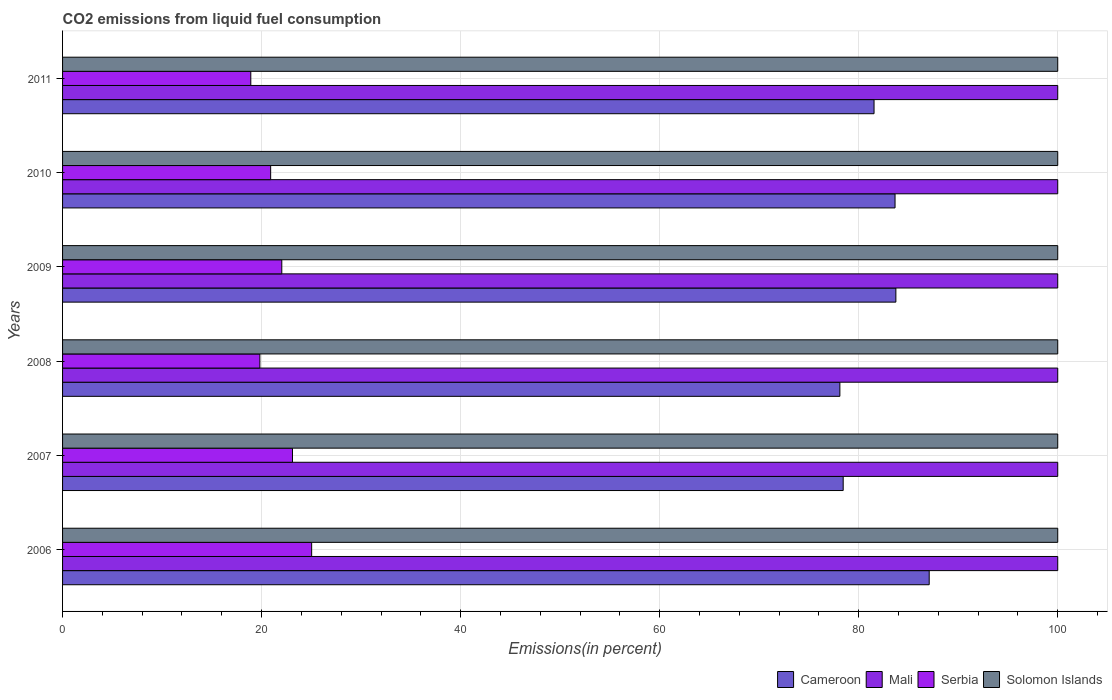Are the number of bars on each tick of the Y-axis equal?
Your answer should be compact. Yes. What is the label of the 6th group of bars from the top?
Give a very brief answer. 2006. In how many cases, is the number of bars for a given year not equal to the number of legend labels?
Your answer should be very brief. 0. What is the total CO2 emitted in Solomon Islands in 2006?
Your answer should be compact. 100. Across all years, what is the maximum total CO2 emitted in Solomon Islands?
Provide a succinct answer. 100. Across all years, what is the minimum total CO2 emitted in Serbia?
Keep it short and to the point. 18.91. In which year was the total CO2 emitted in Cameroon maximum?
Ensure brevity in your answer.  2006. In which year was the total CO2 emitted in Serbia minimum?
Give a very brief answer. 2011. What is the total total CO2 emitted in Solomon Islands in the graph?
Provide a succinct answer. 600. What is the difference between the total CO2 emitted in Cameroon in 2010 and that in 2011?
Make the answer very short. 2.11. What is the difference between the total CO2 emitted in Cameroon in 2006 and the total CO2 emitted in Mali in 2008?
Provide a short and direct response. -12.92. In the year 2008, what is the difference between the total CO2 emitted in Serbia and total CO2 emitted in Solomon Islands?
Your response must be concise. -80.17. In how many years, is the total CO2 emitted in Cameroon greater than 84 %?
Give a very brief answer. 1. What is the ratio of the total CO2 emitted in Cameroon in 2007 to that in 2010?
Your answer should be very brief. 0.94. Is the total CO2 emitted in Cameroon in 2008 less than that in 2011?
Keep it short and to the point. Yes. What is the difference between the highest and the second highest total CO2 emitted in Solomon Islands?
Give a very brief answer. 0. What is the difference between the highest and the lowest total CO2 emitted in Cameroon?
Give a very brief answer. 8.98. In how many years, is the total CO2 emitted in Serbia greater than the average total CO2 emitted in Serbia taken over all years?
Give a very brief answer. 3. Is the sum of the total CO2 emitted in Solomon Islands in 2009 and 2011 greater than the maximum total CO2 emitted in Cameroon across all years?
Offer a very short reply. Yes. Is it the case that in every year, the sum of the total CO2 emitted in Mali and total CO2 emitted in Serbia is greater than the sum of total CO2 emitted in Cameroon and total CO2 emitted in Solomon Islands?
Your response must be concise. No. What does the 1st bar from the top in 2007 represents?
Your response must be concise. Solomon Islands. What does the 4th bar from the bottom in 2008 represents?
Give a very brief answer. Solomon Islands. Are all the bars in the graph horizontal?
Offer a very short reply. Yes. How many years are there in the graph?
Your answer should be very brief. 6. Are the values on the major ticks of X-axis written in scientific E-notation?
Give a very brief answer. No. Does the graph contain any zero values?
Make the answer very short. No. Where does the legend appear in the graph?
Give a very brief answer. Bottom right. What is the title of the graph?
Your response must be concise. CO2 emissions from liquid fuel consumption. What is the label or title of the X-axis?
Keep it short and to the point. Emissions(in percent). What is the label or title of the Y-axis?
Keep it short and to the point. Years. What is the Emissions(in percent) of Cameroon in 2006?
Provide a succinct answer. 87.08. What is the Emissions(in percent) of Serbia in 2006?
Your response must be concise. 25.03. What is the Emissions(in percent) in Solomon Islands in 2006?
Give a very brief answer. 100. What is the Emissions(in percent) in Cameroon in 2007?
Your answer should be very brief. 78.44. What is the Emissions(in percent) in Mali in 2007?
Offer a terse response. 100. What is the Emissions(in percent) in Serbia in 2007?
Your answer should be very brief. 23.1. What is the Emissions(in percent) in Solomon Islands in 2007?
Keep it short and to the point. 100. What is the Emissions(in percent) of Cameroon in 2008?
Your answer should be compact. 78.11. What is the Emissions(in percent) of Mali in 2008?
Offer a very short reply. 100. What is the Emissions(in percent) in Serbia in 2008?
Your response must be concise. 19.83. What is the Emissions(in percent) of Solomon Islands in 2008?
Make the answer very short. 100. What is the Emissions(in percent) of Cameroon in 2009?
Provide a short and direct response. 83.74. What is the Emissions(in percent) of Serbia in 2009?
Provide a short and direct response. 22.03. What is the Emissions(in percent) in Solomon Islands in 2009?
Provide a succinct answer. 100. What is the Emissions(in percent) in Cameroon in 2010?
Provide a succinct answer. 83.65. What is the Emissions(in percent) of Mali in 2010?
Your answer should be very brief. 100. What is the Emissions(in percent) in Serbia in 2010?
Keep it short and to the point. 20.91. What is the Emissions(in percent) of Solomon Islands in 2010?
Your answer should be very brief. 100. What is the Emissions(in percent) of Cameroon in 2011?
Offer a very short reply. 81.54. What is the Emissions(in percent) in Mali in 2011?
Your answer should be compact. 100. What is the Emissions(in percent) of Serbia in 2011?
Make the answer very short. 18.91. What is the Emissions(in percent) in Solomon Islands in 2011?
Offer a terse response. 100. Across all years, what is the maximum Emissions(in percent) in Cameroon?
Make the answer very short. 87.08. Across all years, what is the maximum Emissions(in percent) in Serbia?
Provide a short and direct response. 25.03. Across all years, what is the minimum Emissions(in percent) of Cameroon?
Your answer should be compact. 78.11. Across all years, what is the minimum Emissions(in percent) of Serbia?
Your answer should be very brief. 18.91. What is the total Emissions(in percent) of Cameroon in the graph?
Make the answer very short. 492.56. What is the total Emissions(in percent) of Mali in the graph?
Keep it short and to the point. 600. What is the total Emissions(in percent) of Serbia in the graph?
Your answer should be very brief. 129.81. What is the total Emissions(in percent) in Solomon Islands in the graph?
Offer a terse response. 600. What is the difference between the Emissions(in percent) of Cameroon in 2006 and that in 2007?
Your response must be concise. 8.64. What is the difference between the Emissions(in percent) in Serbia in 2006 and that in 2007?
Provide a short and direct response. 1.93. What is the difference between the Emissions(in percent) in Cameroon in 2006 and that in 2008?
Make the answer very short. 8.98. What is the difference between the Emissions(in percent) in Serbia in 2006 and that in 2008?
Your answer should be compact. 5.2. What is the difference between the Emissions(in percent) of Solomon Islands in 2006 and that in 2008?
Ensure brevity in your answer.  0. What is the difference between the Emissions(in percent) in Cameroon in 2006 and that in 2009?
Provide a succinct answer. 3.35. What is the difference between the Emissions(in percent) of Mali in 2006 and that in 2009?
Ensure brevity in your answer.  0. What is the difference between the Emissions(in percent) in Serbia in 2006 and that in 2009?
Your answer should be compact. 3. What is the difference between the Emissions(in percent) of Cameroon in 2006 and that in 2010?
Give a very brief answer. 3.43. What is the difference between the Emissions(in percent) of Serbia in 2006 and that in 2010?
Provide a short and direct response. 4.12. What is the difference between the Emissions(in percent) in Cameroon in 2006 and that in 2011?
Provide a succinct answer. 5.54. What is the difference between the Emissions(in percent) of Serbia in 2006 and that in 2011?
Keep it short and to the point. 6.12. What is the difference between the Emissions(in percent) in Cameroon in 2007 and that in 2008?
Make the answer very short. 0.33. What is the difference between the Emissions(in percent) in Mali in 2007 and that in 2008?
Your answer should be compact. 0. What is the difference between the Emissions(in percent) in Serbia in 2007 and that in 2008?
Provide a succinct answer. 3.28. What is the difference between the Emissions(in percent) of Solomon Islands in 2007 and that in 2008?
Offer a terse response. 0. What is the difference between the Emissions(in percent) in Cameroon in 2007 and that in 2009?
Your response must be concise. -5.29. What is the difference between the Emissions(in percent) of Mali in 2007 and that in 2009?
Offer a terse response. 0. What is the difference between the Emissions(in percent) of Serbia in 2007 and that in 2009?
Offer a terse response. 1.07. What is the difference between the Emissions(in percent) of Solomon Islands in 2007 and that in 2009?
Make the answer very short. 0. What is the difference between the Emissions(in percent) in Cameroon in 2007 and that in 2010?
Offer a very short reply. -5.21. What is the difference between the Emissions(in percent) in Serbia in 2007 and that in 2010?
Your answer should be compact. 2.19. What is the difference between the Emissions(in percent) in Solomon Islands in 2007 and that in 2010?
Provide a succinct answer. 0. What is the difference between the Emissions(in percent) of Cameroon in 2007 and that in 2011?
Provide a succinct answer. -3.1. What is the difference between the Emissions(in percent) of Serbia in 2007 and that in 2011?
Provide a short and direct response. 4.19. What is the difference between the Emissions(in percent) in Cameroon in 2008 and that in 2009?
Provide a short and direct response. -5.63. What is the difference between the Emissions(in percent) in Serbia in 2008 and that in 2009?
Offer a terse response. -2.2. What is the difference between the Emissions(in percent) of Cameroon in 2008 and that in 2010?
Offer a terse response. -5.54. What is the difference between the Emissions(in percent) in Mali in 2008 and that in 2010?
Your answer should be compact. 0. What is the difference between the Emissions(in percent) of Serbia in 2008 and that in 2010?
Your answer should be compact. -1.08. What is the difference between the Emissions(in percent) in Solomon Islands in 2008 and that in 2010?
Keep it short and to the point. 0. What is the difference between the Emissions(in percent) in Cameroon in 2008 and that in 2011?
Your response must be concise. -3.43. What is the difference between the Emissions(in percent) in Serbia in 2008 and that in 2011?
Your answer should be compact. 0.91. What is the difference between the Emissions(in percent) of Cameroon in 2009 and that in 2010?
Keep it short and to the point. 0.08. What is the difference between the Emissions(in percent) in Serbia in 2009 and that in 2010?
Your answer should be compact. 1.12. What is the difference between the Emissions(in percent) of Cameroon in 2009 and that in 2011?
Your answer should be compact. 2.19. What is the difference between the Emissions(in percent) in Serbia in 2009 and that in 2011?
Your response must be concise. 3.11. What is the difference between the Emissions(in percent) of Solomon Islands in 2009 and that in 2011?
Your response must be concise. 0. What is the difference between the Emissions(in percent) of Cameroon in 2010 and that in 2011?
Provide a short and direct response. 2.11. What is the difference between the Emissions(in percent) of Serbia in 2010 and that in 2011?
Provide a short and direct response. 2. What is the difference between the Emissions(in percent) of Cameroon in 2006 and the Emissions(in percent) of Mali in 2007?
Provide a succinct answer. -12.92. What is the difference between the Emissions(in percent) of Cameroon in 2006 and the Emissions(in percent) of Serbia in 2007?
Your answer should be compact. 63.98. What is the difference between the Emissions(in percent) in Cameroon in 2006 and the Emissions(in percent) in Solomon Islands in 2007?
Your answer should be compact. -12.92. What is the difference between the Emissions(in percent) of Mali in 2006 and the Emissions(in percent) of Serbia in 2007?
Keep it short and to the point. 76.9. What is the difference between the Emissions(in percent) in Mali in 2006 and the Emissions(in percent) in Solomon Islands in 2007?
Give a very brief answer. 0. What is the difference between the Emissions(in percent) in Serbia in 2006 and the Emissions(in percent) in Solomon Islands in 2007?
Ensure brevity in your answer.  -74.97. What is the difference between the Emissions(in percent) of Cameroon in 2006 and the Emissions(in percent) of Mali in 2008?
Make the answer very short. -12.92. What is the difference between the Emissions(in percent) in Cameroon in 2006 and the Emissions(in percent) in Serbia in 2008?
Your answer should be compact. 67.26. What is the difference between the Emissions(in percent) of Cameroon in 2006 and the Emissions(in percent) of Solomon Islands in 2008?
Make the answer very short. -12.92. What is the difference between the Emissions(in percent) of Mali in 2006 and the Emissions(in percent) of Serbia in 2008?
Your response must be concise. 80.17. What is the difference between the Emissions(in percent) of Serbia in 2006 and the Emissions(in percent) of Solomon Islands in 2008?
Your response must be concise. -74.97. What is the difference between the Emissions(in percent) in Cameroon in 2006 and the Emissions(in percent) in Mali in 2009?
Provide a succinct answer. -12.92. What is the difference between the Emissions(in percent) of Cameroon in 2006 and the Emissions(in percent) of Serbia in 2009?
Offer a terse response. 65.06. What is the difference between the Emissions(in percent) of Cameroon in 2006 and the Emissions(in percent) of Solomon Islands in 2009?
Provide a succinct answer. -12.92. What is the difference between the Emissions(in percent) of Mali in 2006 and the Emissions(in percent) of Serbia in 2009?
Offer a very short reply. 77.97. What is the difference between the Emissions(in percent) in Mali in 2006 and the Emissions(in percent) in Solomon Islands in 2009?
Offer a terse response. 0. What is the difference between the Emissions(in percent) in Serbia in 2006 and the Emissions(in percent) in Solomon Islands in 2009?
Your answer should be very brief. -74.97. What is the difference between the Emissions(in percent) in Cameroon in 2006 and the Emissions(in percent) in Mali in 2010?
Offer a very short reply. -12.92. What is the difference between the Emissions(in percent) of Cameroon in 2006 and the Emissions(in percent) of Serbia in 2010?
Offer a terse response. 66.17. What is the difference between the Emissions(in percent) in Cameroon in 2006 and the Emissions(in percent) in Solomon Islands in 2010?
Ensure brevity in your answer.  -12.92. What is the difference between the Emissions(in percent) of Mali in 2006 and the Emissions(in percent) of Serbia in 2010?
Provide a short and direct response. 79.09. What is the difference between the Emissions(in percent) in Mali in 2006 and the Emissions(in percent) in Solomon Islands in 2010?
Ensure brevity in your answer.  0. What is the difference between the Emissions(in percent) of Serbia in 2006 and the Emissions(in percent) of Solomon Islands in 2010?
Keep it short and to the point. -74.97. What is the difference between the Emissions(in percent) of Cameroon in 2006 and the Emissions(in percent) of Mali in 2011?
Offer a terse response. -12.92. What is the difference between the Emissions(in percent) in Cameroon in 2006 and the Emissions(in percent) in Serbia in 2011?
Keep it short and to the point. 68.17. What is the difference between the Emissions(in percent) in Cameroon in 2006 and the Emissions(in percent) in Solomon Islands in 2011?
Keep it short and to the point. -12.92. What is the difference between the Emissions(in percent) in Mali in 2006 and the Emissions(in percent) in Serbia in 2011?
Keep it short and to the point. 81.09. What is the difference between the Emissions(in percent) of Serbia in 2006 and the Emissions(in percent) of Solomon Islands in 2011?
Provide a succinct answer. -74.97. What is the difference between the Emissions(in percent) of Cameroon in 2007 and the Emissions(in percent) of Mali in 2008?
Provide a short and direct response. -21.56. What is the difference between the Emissions(in percent) in Cameroon in 2007 and the Emissions(in percent) in Serbia in 2008?
Make the answer very short. 58.62. What is the difference between the Emissions(in percent) in Cameroon in 2007 and the Emissions(in percent) in Solomon Islands in 2008?
Offer a terse response. -21.56. What is the difference between the Emissions(in percent) in Mali in 2007 and the Emissions(in percent) in Serbia in 2008?
Your answer should be very brief. 80.17. What is the difference between the Emissions(in percent) of Mali in 2007 and the Emissions(in percent) of Solomon Islands in 2008?
Offer a terse response. 0. What is the difference between the Emissions(in percent) in Serbia in 2007 and the Emissions(in percent) in Solomon Islands in 2008?
Your answer should be very brief. -76.9. What is the difference between the Emissions(in percent) of Cameroon in 2007 and the Emissions(in percent) of Mali in 2009?
Offer a very short reply. -21.56. What is the difference between the Emissions(in percent) in Cameroon in 2007 and the Emissions(in percent) in Serbia in 2009?
Keep it short and to the point. 56.41. What is the difference between the Emissions(in percent) in Cameroon in 2007 and the Emissions(in percent) in Solomon Islands in 2009?
Provide a short and direct response. -21.56. What is the difference between the Emissions(in percent) of Mali in 2007 and the Emissions(in percent) of Serbia in 2009?
Provide a succinct answer. 77.97. What is the difference between the Emissions(in percent) in Mali in 2007 and the Emissions(in percent) in Solomon Islands in 2009?
Provide a succinct answer. 0. What is the difference between the Emissions(in percent) in Serbia in 2007 and the Emissions(in percent) in Solomon Islands in 2009?
Provide a succinct answer. -76.9. What is the difference between the Emissions(in percent) in Cameroon in 2007 and the Emissions(in percent) in Mali in 2010?
Offer a terse response. -21.56. What is the difference between the Emissions(in percent) of Cameroon in 2007 and the Emissions(in percent) of Serbia in 2010?
Offer a very short reply. 57.53. What is the difference between the Emissions(in percent) of Cameroon in 2007 and the Emissions(in percent) of Solomon Islands in 2010?
Provide a succinct answer. -21.56. What is the difference between the Emissions(in percent) of Mali in 2007 and the Emissions(in percent) of Serbia in 2010?
Keep it short and to the point. 79.09. What is the difference between the Emissions(in percent) of Mali in 2007 and the Emissions(in percent) of Solomon Islands in 2010?
Provide a succinct answer. 0. What is the difference between the Emissions(in percent) in Serbia in 2007 and the Emissions(in percent) in Solomon Islands in 2010?
Offer a very short reply. -76.9. What is the difference between the Emissions(in percent) of Cameroon in 2007 and the Emissions(in percent) of Mali in 2011?
Your answer should be compact. -21.56. What is the difference between the Emissions(in percent) in Cameroon in 2007 and the Emissions(in percent) in Serbia in 2011?
Keep it short and to the point. 59.53. What is the difference between the Emissions(in percent) of Cameroon in 2007 and the Emissions(in percent) of Solomon Islands in 2011?
Offer a terse response. -21.56. What is the difference between the Emissions(in percent) in Mali in 2007 and the Emissions(in percent) in Serbia in 2011?
Offer a terse response. 81.09. What is the difference between the Emissions(in percent) of Mali in 2007 and the Emissions(in percent) of Solomon Islands in 2011?
Your answer should be very brief. 0. What is the difference between the Emissions(in percent) of Serbia in 2007 and the Emissions(in percent) of Solomon Islands in 2011?
Your answer should be compact. -76.9. What is the difference between the Emissions(in percent) of Cameroon in 2008 and the Emissions(in percent) of Mali in 2009?
Offer a terse response. -21.89. What is the difference between the Emissions(in percent) of Cameroon in 2008 and the Emissions(in percent) of Serbia in 2009?
Provide a succinct answer. 56.08. What is the difference between the Emissions(in percent) in Cameroon in 2008 and the Emissions(in percent) in Solomon Islands in 2009?
Your response must be concise. -21.89. What is the difference between the Emissions(in percent) of Mali in 2008 and the Emissions(in percent) of Serbia in 2009?
Ensure brevity in your answer.  77.97. What is the difference between the Emissions(in percent) in Serbia in 2008 and the Emissions(in percent) in Solomon Islands in 2009?
Make the answer very short. -80.17. What is the difference between the Emissions(in percent) in Cameroon in 2008 and the Emissions(in percent) in Mali in 2010?
Your answer should be very brief. -21.89. What is the difference between the Emissions(in percent) of Cameroon in 2008 and the Emissions(in percent) of Serbia in 2010?
Your response must be concise. 57.2. What is the difference between the Emissions(in percent) in Cameroon in 2008 and the Emissions(in percent) in Solomon Islands in 2010?
Your response must be concise. -21.89. What is the difference between the Emissions(in percent) in Mali in 2008 and the Emissions(in percent) in Serbia in 2010?
Give a very brief answer. 79.09. What is the difference between the Emissions(in percent) in Serbia in 2008 and the Emissions(in percent) in Solomon Islands in 2010?
Give a very brief answer. -80.17. What is the difference between the Emissions(in percent) in Cameroon in 2008 and the Emissions(in percent) in Mali in 2011?
Offer a very short reply. -21.89. What is the difference between the Emissions(in percent) in Cameroon in 2008 and the Emissions(in percent) in Serbia in 2011?
Give a very brief answer. 59.19. What is the difference between the Emissions(in percent) of Cameroon in 2008 and the Emissions(in percent) of Solomon Islands in 2011?
Keep it short and to the point. -21.89. What is the difference between the Emissions(in percent) in Mali in 2008 and the Emissions(in percent) in Serbia in 2011?
Provide a succinct answer. 81.09. What is the difference between the Emissions(in percent) in Serbia in 2008 and the Emissions(in percent) in Solomon Islands in 2011?
Ensure brevity in your answer.  -80.17. What is the difference between the Emissions(in percent) of Cameroon in 2009 and the Emissions(in percent) of Mali in 2010?
Provide a succinct answer. -16.26. What is the difference between the Emissions(in percent) in Cameroon in 2009 and the Emissions(in percent) in Serbia in 2010?
Give a very brief answer. 62.83. What is the difference between the Emissions(in percent) of Cameroon in 2009 and the Emissions(in percent) of Solomon Islands in 2010?
Keep it short and to the point. -16.26. What is the difference between the Emissions(in percent) in Mali in 2009 and the Emissions(in percent) in Serbia in 2010?
Ensure brevity in your answer.  79.09. What is the difference between the Emissions(in percent) in Mali in 2009 and the Emissions(in percent) in Solomon Islands in 2010?
Offer a terse response. 0. What is the difference between the Emissions(in percent) of Serbia in 2009 and the Emissions(in percent) of Solomon Islands in 2010?
Give a very brief answer. -77.97. What is the difference between the Emissions(in percent) in Cameroon in 2009 and the Emissions(in percent) in Mali in 2011?
Offer a very short reply. -16.26. What is the difference between the Emissions(in percent) of Cameroon in 2009 and the Emissions(in percent) of Serbia in 2011?
Your response must be concise. 64.82. What is the difference between the Emissions(in percent) of Cameroon in 2009 and the Emissions(in percent) of Solomon Islands in 2011?
Offer a very short reply. -16.26. What is the difference between the Emissions(in percent) of Mali in 2009 and the Emissions(in percent) of Serbia in 2011?
Keep it short and to the point. 81.09. What is the difference between the Emissions(in percent) in Serbia in 2009 and the Emissions(in percent) in Solomon Islands in 2011?
Give a very brief answer. -77.97. What is the difference between the Emissions(in percent) of Cameroon in 2010 and the Emissions(in percent) of Mali in 2011?
Provide a succinct answer. -16.35. What is the difference between the Emissions(in percent) of Cameroon in 2010 and the Emissions(in percent) of Serbia in 2011?
Provide a succinct answer. 64.74. What is the difference between the Emissions(in percent) in Cameroon in 2010 and the Emissions(in percent) in Solomon Islands in 2011?
Ensure brevity in your answer.  -16.35. What is the difference between the Emissions(in percent) of Mali in 2010 and the Emissions(in percent) of Serbia in 2011?
Offer a terse response. 81.09. What is the difference between the Emissions(in percent) of Mali in 2010 and the Emissions(in percent) of Solomon Islands in 2011?
Keep it short and to the point. 0. What is the difference between the Emissions(in percent) of Serbia in 2010 and the Emissions(in percent) of Solomon Islands in 2011?
Your response must be concise. -79.09. What is the average Emissions(in percent) of Cameroon per year?
Keep it short and to the point. 82.09. What is the average Emissions(in percent) of Serbia per year?
Offer a very short reply. 21.64. What is the average Emissions(in percent) in Solomon Islands per year?
Give a very brief answer. 100. In the year 2006, what is the difference between the Emissions(in percent) of Cameroon and Emissions(in percent) of Mali?
Your answer should be compact. -12.92. In the year 2006, what is the difference between the Emissions(in percent) in Cameroon and Emissions(in percent) in Serbia?
Keep it short and to the point. 62.05. In the year 2006, what is the difference between the Emissions(in percent) of Cameroon and Emissions(in percent) of Solomon Islands?
Your answer should be compact. -12.92. In the year 2006, what is the difference between the Emissions(in percent) of Mali and Emissions(in percent) of Serbia?
Make the answer very short. 74.97. In the year 2006, what is the difference between the Emissions(in percent) of Serbia and Emissions(in percent) of Solomon Islands?
Offer a very short reply. -74.97. In the year 2007, what is the difference between the Emissions(in percent) of Cameroon and Emissions(in percent) of Mali?
Provide a short and direct response. -21.56. In the year 2007, what is the difference between the Emissions(in percent) of Cameroon and Emissions(in percent) of Serbia?
Keep it short and to the point. 55.34. In the year 2007, what is the difference between the Emissions(in percent) of Cameroon and Emissions(in percent) of Solomon Islands?
Offer a very short reply. -21.56. In the year 2007, what is the difference between the Emissions(in percent) in Mali and Emissions(in percent) in Serbia?
Provide a succinct answer. 76.9. In the year 2007, what is the difference between the Emissions(in percent) of Serbia and Emissions(in percent) of Solomon Islands?
Offer a terse response. -76.9. In the year 2008, what is the difference between the Emissions(in percent) of Cameroon and Emissions(in percent) of Mali?
Your answer should be very brief. -21.89. In the year 2008, what is the difference between the Emissions(in percent) in Cameroon and Emissions(in percent) in Serbia?
Offer a very short reply. 58.28. In the year 2008, what is the difference between the Emissions(in percent) of Cameroon and Emissions(in percent) of Solomon Islands?
Ensure brevity in your answer.  -21.89. In the year 2008, what is the difference between the Emissions(in percent) of Mali and Emissions(in percent) of Serbia?
Your answer should be compact. 80.17. In the year 2008, what is the difference between the Emissions(in percent) of Serbia and Emissions(in percent) of Solomon Islands?
Your answer should be very brief. -80.17. In the year 2009, what is the difference between the Emissions(in percent) of Cameroon and Emissions(in percent) of Mali?
Offer a very short reply. -16.26. In the year 2009, what is the difference between the Emissions(in percent) in Cameroon and Emissions(in percent) in Serbia?
Your response must be concise. 61.71. In the year 2009, what is the difference between the Emissions(in percent) in Cameroon and Emissions(in percent) in Solomon Islands?
Make the answer very short. -16.26. In the year 2009, what is the difference between the Emissions(in percent) in Mali and Emissions(in percent) in Serbia?
Ensure brevity in your answer.  77.97. In the year 2009, what is the difference between the Emissions(in percent) of Mali and Emissions(in percent) of Solomon Islands?
Your answer should be compact. 0. In the year 2009, what is the difference between the Emissions(in percent) of Serbia and Emissions(in percent) of Solomon Islands?
Offer a very short reply. -77.97. In the year 2010, what is the difference between the Emissions(in percent) in Cameroon and Emissions(in percent) in Mali?
Offer a terse response. -16.35. In the year 2010, what is the difference between the Emissions(in percent) in Cameroon and Emissions(in percent) in Serbia?
Your answer should be compact. 62.74. In the year 2010, what is the difference between the Emissions(in percent) of Cameroon and Emissions(in percent) of Solomon Islands?
Provide a succinct answer. -16.35. In the year 2010, what is the difference between the Emissions(in percent) in Mali and Emissions(in percent) in Serbia?
Offer a terse response. 79.09. In the year 2010, what is the difference between the Emissions(in percent) in Serbia and Emissions(in percent) in Solomon Islands?
Provide a succinct answer. -79.09. In the year 2011, what is the difference between the Emissions(in percent) of Cameroon and Emissions(in percent) of Mali?
Your answer should be compact. -18.46. In the year 2011, what is the difference between the Emissions(in percent) in Cameroon and Emissions(in percent) in Serbia?
Your answer should be compact. 62.63. In the year 2011, what is the difference between the Emissions(in percent) of Cameroon and Emissions(in percent) of Solomon Islands?
Keep it short and to the point. -18.46. In the year 2011, what is the difference between the Emissions(in percent) in Mali and Emissions(in percent) in Serbia?
Offer a very short reply. 81.09. In the year 2011, what is the difference between the Emissions(in percent) of Mali and Emissions(in percent) of Solomon Islands?
Make the answer very short. 0. In the year 2011, what is the difference between the Emissions(in percent) of Serbia and Emissions(in percent) of Solomon Islands?
Make the answer very short. -81.09. What is the ratio of the Emissions(in percent) of Cameroon in 2006 to that in 2007?
Ensure brevity in your answer.  1.11. What is the ratio of the Emissions(in percent) of Mali in 2006 to that in 2007?
Provide a succinct answer. 1. What is the ratio of the Emissions(in percent) in Serbia in 2006 to that in 2007?
Provide a short and direct response. 1.08. What is the ratio of the Emissions(in percent) in Solomon Islands in 2006 to that in 2007?
Your answer should be compact. 1. What is the ratio of the Emissions(in percent) of Cameroon in 2006 to that in 2008?
Your response must be concise. 1.11. What is the ratio of the Emissions(in percent) of Mali in 2006 to that in 2008?
Your answer should be very brief. 1. What is the ratio of the Emissions(in percent) of Serbia in 2006 to that in 2008?
Your answer should be compact. 1.26. What is the ratio of the Emissions(in percent) in Cameroon in 2006 to that in 2009?
Ensure brevity in your answer.  1.04. What is the ratio of the Emissions(in percent) in Serbia in 2006 to that in 2009?
Provide a succinct answer. 1.14. What is the ratio of the Emissions(in percent) in Cameroon in 2006 to that in 2010?
Your answer should be very brief. 1.04. What is the ratio of the Emissions(in percent) of Mali in 2006 to that in 2010?
Provide a short and direct response. 1. What is the ratio of the Emissions(in percent) of Serbia in 2006 to that in 2010?
Offer a very short reply. 1.2. What is the ratio of the Emissions(in percent) of Solomon Islands in 2006 to that in 2010?
Offer a terse response. 1. What is the ratio of the Emissions(in percent) in Cameroon in 2006 to that in 2011?
Your answer should be very brief. 1.07. What is the ratio of the Emissions(in percent) of Mali in 2006 to that in 2011?
Offer a very short reply. 1. What is the ratio of the Emissions(in percent) of Serbia in 2006 to that in 2011?
Give a very brief answer. 1.32. What is the ratio of the Emissions(in percent) of Mali in 2007 to that in 2008?
Offer a terse response. 1. What is the ratio of the Emissions(in percent) in Serbia in 2007 to that in 2008?
Keep it short and to the point. 1.17. What is the ratio of the Emissions(in percent) in Cameroon in 2007 to that in 2009?
Your response must be concise. 0.94. What is the ratio of the Emissions(in percent) of Serbia in 2007 to that in 2009?
Offer a terse response. 1.05. What is the ratio of the Emissions(in percent) in Cameroon in 2007 to that in 2010?
Provide a succinct answer. 0.94. What is the ratio of the Emissions(in percent) of Serbia in 2007 to that in 2010?
Provide a succinct answer. 1.1. What is the ratio of the Emissions(in percent) in Solomon Islands in 2007 to that in 2010?
Make the answer very short. 1. What is the ratio of the Emissions(in percent) of Cameroon in 2007 to that in 2011?
Offer a very short reply. 0.96. What is the ratio of the Emissions(in percent) of Mali in 2007 to that in 2011?
Your answer should be compact. 1. What is the ratio of the Emissions(in percent) in Serbia in 2007 to that in 2011?
Your answer should be compact. 1.22. What is the ratio of the Emissions(in percent) of Solomon Islands in 2007 to that in 2011?
Your answer should be very brief. 1. What is the ratio of the Emissions(in percent) in Cameroon in 2008 to that in 2009?
Your response must be concise. 0.93. What is the ratio of the Emissions(in percent) in Mali in 2008 to that in 2009?
Make the answer very short. 1. What is the ratio of the Emissions(in percent) of Cameroon in 2008 to that in 2010?
Keep it short and to the point. 0.93. What is the ratio of the Emissions(in percent) in Mali in 2008 to that in 2010?
Offer a terse response. 1. What is the ratio of the Emissions(in percent) of Serbia in 2008 to that in 2010?
Offer a very short reply. 0.95. What is the ratio of the Emissions(in percent) in Cameroon in 2008 to that in 2011?
Provide a succinct answer. 0.96. What is the ratio of the Emissions(in percent) of Serbia in 2008 to that in 2011?
Provide a short and direct response. 1.05. What is the ratio of the Emissions(in percent) in Solomon Islands in 2008 to that in 2011?
Offer a terse response. 1. What is the ratio of the Emissions(in percent) in Cameroon in 2009 to that in 2010?
Keep it short and to the point. 1. What is the ratio of the Emissions(in percent) of Serbia in 2009 to that in 2010?
Keep it short and to the point. 1.05. What is the ratio of the Emissions(in percent) of Cameroon in 2009 to that in 2011?
Your response must be concise. 1.03. What is the ratio of the Emissions(in percent) of Serbia in 2009 to that in 2011?
Offer a terse response. 1.16. What is the ratio of the Emissions(in percent) in Solomon Islands in 2009 to that in 2011?
Offer a very short reply. 1. What is the ratio of the Emissions(in percent) of Cameroon in 2010 to that in 2011?
Keep it short and to the point. 1.03. What is the ratio of the Emissions(in percent) in Serbia in 2010 to that in 2011?
Your response must be concise. 1.11. What is the ratio of the Emissions(in percent) of Solomon Islands in 2010 to that in 2011?
Offer a terse response. 1. What is the difference between the highest and the second highest Emissions(in percent) of Cameroon?
Provide a short and direct response. 3.35. What is the difference between the highest and the second highest Emissions(in percent) in Mali?
Provide a succinct answer. 0. What is the difference between the highest and the second highest Emissions(in percent) of Serbia?
Provide a succinct answer. 1.93. What is the difference between the highest and the lowest Emissions(in percent) of Cameroon?
Your answer should be compact. 8.98. What is the difference between the highest and the lowest Emissions(in percent) of Mali?
Keep it short and to the point. 0. What is the difference between the highest and the lowest Emissions(in percent) of Serbia?
Offer a very short reply. 6.12. What is the difference between the highest and the lowest Emissions(in percent) in Solomon Islands?
Make the answer very short. 0. 